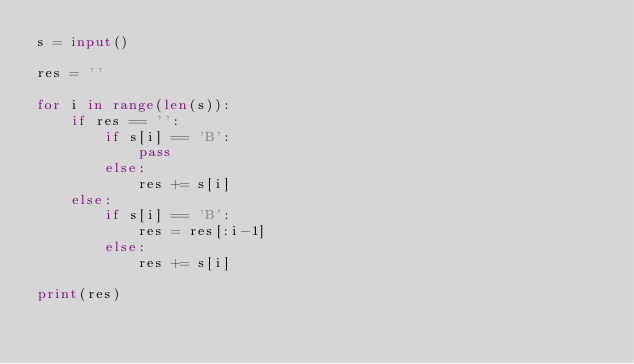<code> <loc_0><loc_0><loc_500><loc_500><_Python_>s = input()

res = ''

for i in range(len(s)):
    if res == '':
        if s[i] == 'B':
            pass
        else:
            res += s[i]
    else:
        if s[i] == 'B':
            res = res[:i-1]
        else:
            res += s[i]
    
print(res)</code> 